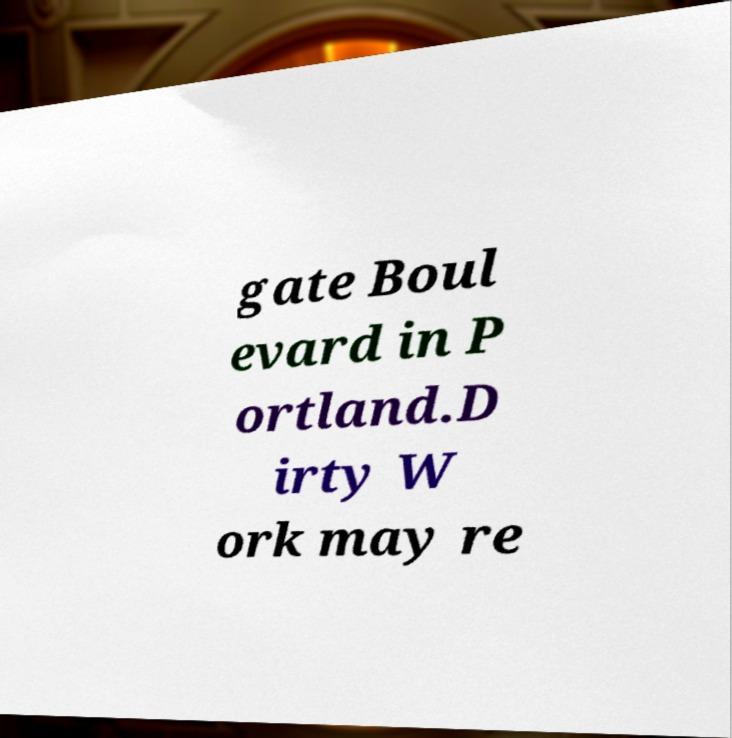Can you accurately transcribe the text from the provided image for me? gate Boul evard in P ortland.D irty W ork may re 